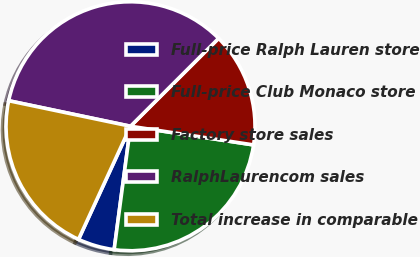<chart> <loc_0><loc_0><loc_500><loc_500><pie_chart><fcel>Full-price Ralph Lauren store<fcel>Full-price Club Monaco store<fcel>Factory store sales<fcel>RalphLaurencom sales<fcel>Total increase in comparable<nl><fcel>4.76%<fcel>24.7%<fcel>14.88%<fcel>34.23%<fcel>21.43%<nl></chart> 